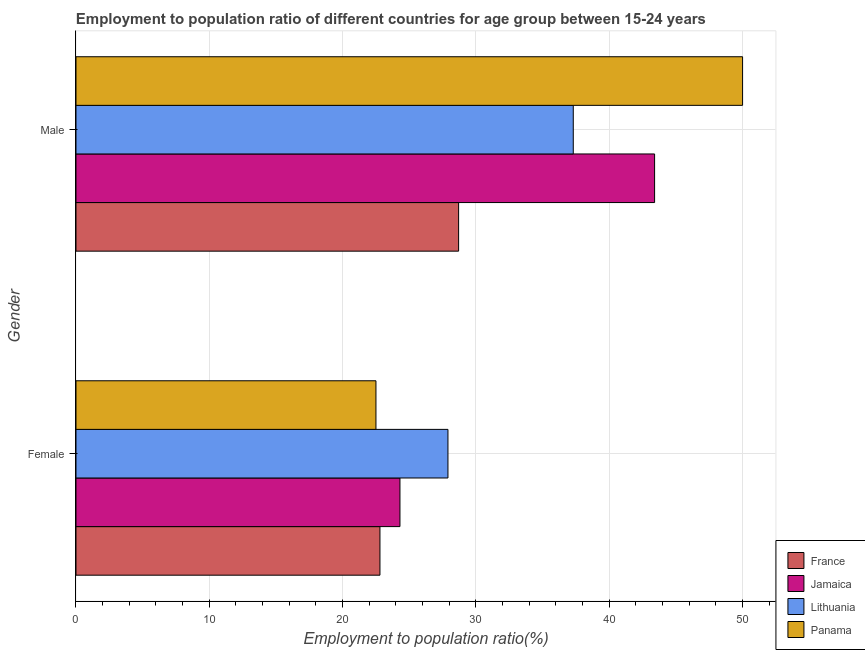How many different coloured bars are there?
Your response must be concise. 4. How many groups of bars are there?
Offer a very short reply. 2. What is the employment to population ratio(female) in France?
Provide a short and direct response. 22.8. Across all countries, what is the maximum employment to population ratio(female)?
Make the answer very short. 27.9. Across all countries, what is the minimum employment to population ratio(male)?
Ensure brevity in your answer.  28.7. In which country was the employment to population ratio(female) maximum?
Provide a short and direct response. Lithuania. In which country was the employment to population ratio(male) minimum?
Your response must be concise. France. What is the total employment to population ratio(female) in the graph?
Keep it short and to the point. 97.5. What is the difference between the employment to population ratio(male) in France and that in Lithuania?
Provide a succinct answer. -8.6. What is the difference between the employment to population ratio(male) in Panama and the employment to population ratio(female) in Lithuania?
Offer a terse response. 22.1. What is the average employment to population ratio(male) per country?
Offer a terse response. 39.85. What is the difference between the employment to population ratio(female) and employment to population ratio(male) in Jamaica?
Your answer should be compact. -19.1. In how many countries, is the employment to population ratio(male) greater than 20 %?
Give a very brief answer. 4. What is the ratio of the employment to population ratio(male) in France to that in Lithuania?
Your answer should be very brief. 0.77. What does the 2nd bar from the top in Male represents?
Make the answer very short. Lithuania. What does the 1st bar from the bottom in Female represents?
Provide a short and direct response. France. How many bars are there?
Give a very brief answer. 8. Are all the bars in the graph horizontal?
Provide a succinct answer. Yes. What is the difference between two consecutive major ticks on the X-axis?
Your answer should be compact. 10. Where does the legend appear in the graph?
Make the answer very short. Bottom right. What is the title of the graph?
Make the answer very short. Employment to population ratio of different countries for age group between 15-24 years. What is the label or title of the X-axis?
Provide a succinct answer. Employment to population ratio(%). What is the label or title of the Y-axis?
Provide a succinct answer. Gender. What is the Employment to population ratio(%) in France in Female?
Offer a very short reply. 22.8. What is the Employment to population ratio(%) in Jamaica in Female?
Offer a very short reply. 24.3. What is the Employment to population ratio(%) of Lithuania in Female?
Make the answer very short. 27.9. What is the Employment to population ratio(%) of Panama in Female?
Offer a very short reply. 22.5. What is the Employment to population ratio(%) of France in Male?
Give a very brief answer. 28.7. What is the Employment to population ratio(%) in Jamaica in Male?
Your response must be concise. 43.4. What is the Employment to population ratio(%) in Lithuania in Male?
Ensure brevity in your answer.  37.3. What is the Employment to population ratio(%) in Panama in Male?
Your response must be concise. 50. Across all Gender, what is the maximum Employment to population ratio(%) of France?
Provide a short and direct response. 28.7. Across all Gender, what is the maximum Employment to population ratio(%) in Jamaica?
Provide a short and direct response. 43.4. Across all Gender, what is the maximum Employment to population ratio(%) in Lithuania?
Your answer should be very brief. 37.3. Across all Gender, what is the maximum Employment to population ratio(%) of Panama?
Make the answer very short. 50. Across all Gender, what is the minimum Employment to population ratio(%) in France?
Your answer should be very brief. 22.8. Across all Gender, what is the minimum Employment to population ratio(%) of Jamaica?
Give a very brief answer. 24.3. Across all Gender, what is the minimum Employment to population ratio(%) in Lithuania?
Keep it short and to the point. 27.9. What is the total Employment to population ratio(%) in France in the graph?
Your answer should be very brief. 51.5. What is the total Employment to population ratio(%) in Jamaica in the graph?
Your response must be concise. 67.7. What is the total Employment to population ratio(%) of Lithuania in the graph?
Provide a succinct answer. 65.2. What is the total Employment to population ratio(%) in Panama in the graph?
Make the answer very short. 72.5. What is the difference between the Employment to population ratio(%) in Jamaica in Female and that in Male?
Your response must be concise. -19.1. What is the difference between the Employment to population ratio(%) of Panama in Female and that in Male?
Offer a very short reply. -27.5. What is the difference between the Employment to population ratio(%) of France in Female and the Employment to population ratio(%) of Jamaica in Male?
Your response must be concise. -20.6. What is the difference between the Employment to population ratio(%) in France in Female and the Employment to population ratio(%) in Panama in Male?
Give a very brief answer. -27.2. What is the difference between the Employment to population ratio(%) of Jamaica in Female and the Employment to population ratio(%) of Panama in Male?
Ensure brevity in your answer.  -25.7. What is the difference between the Employment to population ratio(%) in Lithuania in Female and the Employment to population ratio(%) in Panama in Male?
Keep it short and to the point. -22.1. What is the average Employment to population ratio(%) of France per Gender?
Keep it short and to the point. 25.75. What is the average Employment to population ratio(%) of Jamaica per Gender?
Make the answer very short. 33.85. What is the average Employment to population ratio(%) in Lithuania per Gender?
Keep it short and to the point. 32.6. What is the average Employment to population ratio(%) in Panama per Gender?
Give a very brief answer. 36.25. What is the difference between the Employment to population ratio(%) in France and Employment to population ratio(%) in Lithuania in Female?
Your answer should be compact. -5.1. What is the difference between the Employment to population ratio(%) of France and Employment to population ratio(%) of Panama in Female?
Ensure brevity in your answer.  0.3. What is the difference between the Employment to population ratio(%) in Jamaica and Employment to population ratio(%) in Lithuania in Female?
Give a very brief answer. -3.6. What is the difference between the Employment to population ratio(%) in Jamaica and Employment to population ratio(%) in Panama in Female?
Your response must be concise. 1.8. What is the difference between the Employment to population ratio(%) of France and Employment to population ratio(%) of Jamaica in Male?
Keep it short and to the point. -14.7. What is the difference between the Employment to population ratio(%) in France and Employment to population ratio(%) in Panama in Male?
Make the answer very short. -21.3. What is the difference between the Employment to population ratio(%) in Jamaica and Employment to population ratio(%) in Lithuania in Male?
Your answer should be compact. 6.1. What is the difference between the Employment to population ratio(%) in Lithuania and Employment to population ratio(%) in Panama in Male?
Keep it short and to the point. -12.7. What is the ratio of the Employment to population ratio(%) of France in Female to that in Male?
Make the answer very short. 0.79. What is the ratio of the Employment to population ratio(%) of Jamaica in Female to that in Male?
Your answer should be compact. 0.56. What is the ratio of the Employment to population ratio(%) of Lithuania in Female to that in Male?
Offer a terse response. 0.75. What is the ratio of the Employment to population ratio(%) in Panama in Female to that in Male?
Offer a terse response. 0.45. What is the difference between the highest and the second highest Employment to population ratio(%) in Jamaica?
Offer a very short reply. 19.1. What is the difference between the highest and the second highest Employment to population ratio(%) of Lithuania?
Keep it short and to the point. 9.4. What is the difference between the highest and the second highest Employment to population ratio(%) in Panama?
Make the answer very short. 27.5. What is the difference between the highest and the lowest Employment to population ratio(%) of Jamaica?
Your answer should be very brief. 19.1. What is the difference between the highest and the lowest Employment to population ratio(%) of Panama?
Give a very brief answer. 27.5. 